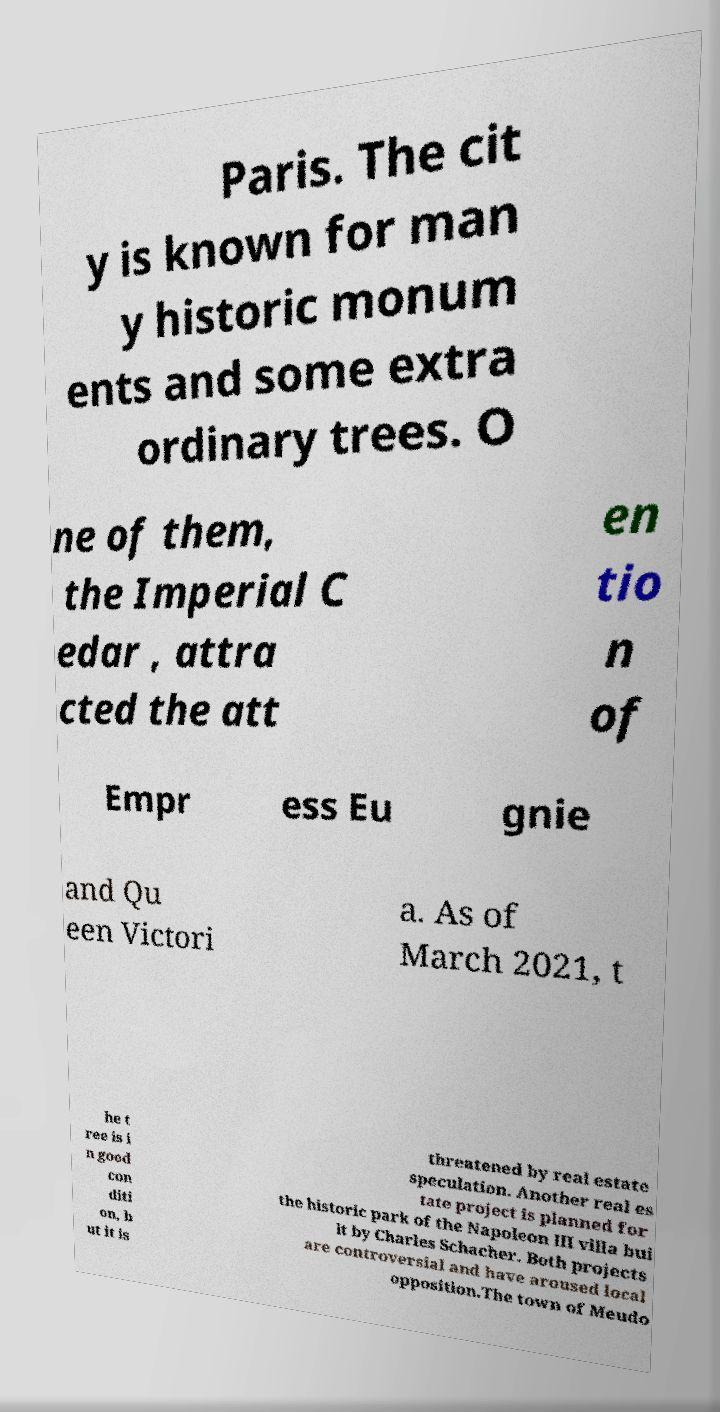Could you assist in decoding the text presented in this image and type it out clearly? Paris. The cit y is known for man y historic monum ents and some extra ordinary trees. O ne of them, the Imperial C edar , attra cted the att en tio n of Empr ess Eu gnie and Qu een Victori a. As of March 2021, t he t ree is i n good con diti on, b ut it is threatened by real estate speculation. Another real es tate project is planned for the historic park of the Napoleon III villa bui lt by Charles Schacher. Both projects are controversial and have aroused local opposition.The town of Meudo 